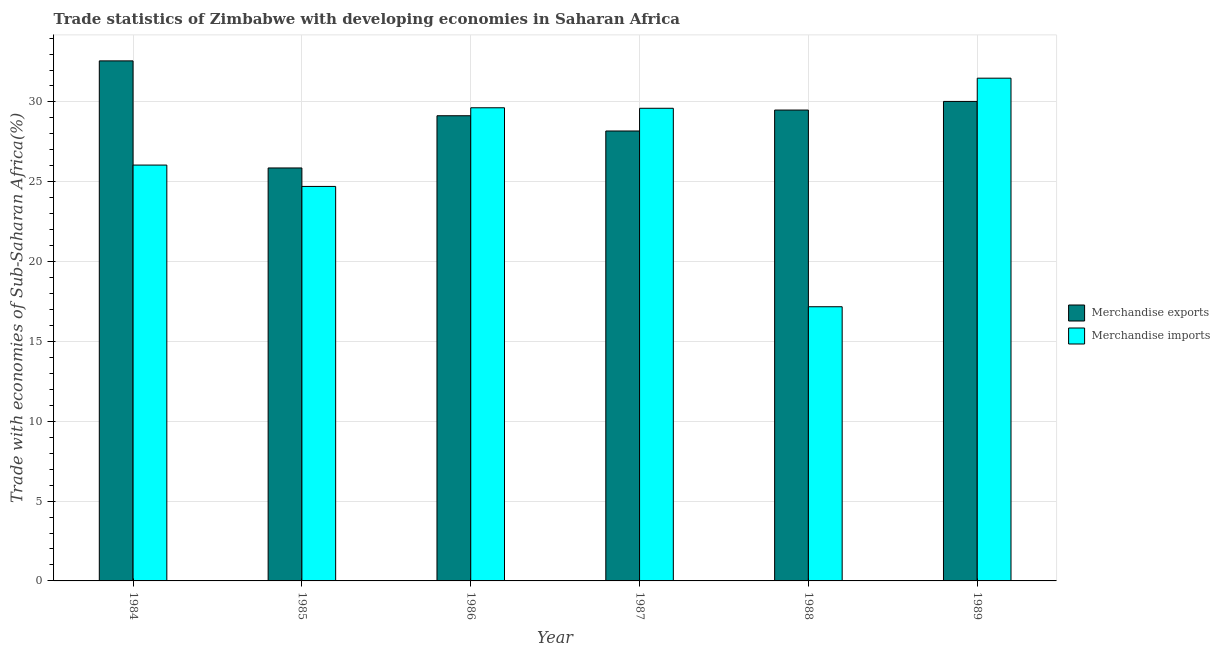How many different coloured bars are there?
Provide a short and direct response. 2. How many groups of bars are there?
Make the answer very short. 6. Are the number of bars on each tick of the X-axis equal?
Your answer should be very brief. Yes. How many bars are there on the 5th tick from the left?
Offer a very short reply. 2. How many bars are there on the 1st tick from the right?
Your response must be concise. 2. In how many cases, is the number of bars for a given year not equal to the number of legend labels?
Your answer should be compact. 0. What is the merchandise imports in 1989?
Make the answer very short. 31.49. Across all years, what is the maximum merchandise imports?
Your answer should be compact. 31.49. Across all years, what is the minimum merchandise imports?
Your answer should be compact. 17.17. In which year was the merchandise exports minimum?
Your response must be concise. 1985. What is the total merchandise exports in the graph?
Your answer should be compact. 175.28. What is the difference between the merchandise imports in 1986 and that in 1988?
Provide a short and direct response. 12.46. What is the difference between the merchandise imports in 1987 and the merchandise exports in 1989?
Your response must be concise. -1.88. What is the average merchandise exports per year?
Keep it short and to the point. 29.21. In the year 1988, what is the difference between the merchandise imports and merchandise exports?
Make the answer very short. 0. In how many years, is the merchandise exports greater than 29 %?
Provide a succinct answer. 4. What is the ratio of the merchandise imports in 1986 to that in 1988?
Offer a terse response. 1.73. Is the difference between the merchandise exports in 1985 and 1988 greater than the difference between the merchandise imports in 1985 and 1988?
Give a very brief answer. No. What is the difference between the highest and the second highest merchandise exports?
Give a very brief answer. 2.54. What is the difference between the highest and the lowest merchandise exports?
Offer a very short reply. 6.71. In how many years, is the merchandise exports greater than the average merchandise exports taken over all years?
Ensure brevity in your answer.  3. What does the 2nd bar from the left in 1989 represents?
Your answer should be very brief. Merchandise imports. What does the 2nd bar from the right in 1985 represents?
Make the answer very short. Merchandise exports. Are all the bars in the graph horizontal?
Offer a very short reply. No. What is the difference between two consecutive major ticks on the Y-axis?
Offer a terse response. 5. Does the graph contain grids?
Provide a succinct answer. Yes. Where does the legend appear in the graph?
Provide a short and direct response. Center right. How many legend labels are there?
Give a very brief answer. 2. How are the legend labels stacked?
Ensure brevity in your answer.  Vertical. What is the title of the graph?
Your answer should be compact. Trade statistics of Zimbabwe with developing economies in Saharan Africa. What is the label or title of the X-axis?
Keep it short and to the point. Year. What is the label or title of the Y-axis?
Provide a succinct answer. Trade with economies of Sub-Saharan Africa(%). What is the Trade with economies of Sub-Saharan Africa(%) of Merchandise exports in 1984?
Offer a terse response. 32.57. What is the Trade with economies of Sub-Saharan Africa(%) in Merchandise imports in 1984?
Offer a very short reply. 26.05. What is the Trade with economies of Sub-Saharan Africa(%) in Merchandise exports in 1985?
Offer a very short reply. 25.87. What is the Trade with economies of Sub-Saharan Africa(%) in Merchandise imports in 1985?
Your response must be concise. 24.71. What is the Trade with economies of Sub-Saharan Africa(%) of Merchandise exports in 1986?
Make the answer very short. 29.14. What is the Trade with economies of Sub-Saharan Africa(%) of Merchandise imports in 1986?
Give a very brief answer. 29.63. What is the Trade with economies of Sub-Saharan Africa(%) in Merchandise exports in 1987?
Offer a very short reply. 28.18. What is the Trade with economies of Sub-Saharan Africa(%) in Merchandise imports in 1987?
Provide a succinct answer. 29.6. What is the Trade with economies of Sub-Saharan Africa(%) in Merchandise exports in 1988?
Your answer should be very brief. 29.49. What is the Trade with economies of Sub-Saharan Africa(%) of Merchandise imports in 1988?
Offer a terse response. 17.17. What is the Trade with economies of Sub-Saharan Africa(%) in Merchandise exports in 1989?
Your answer should be compact. 30.03. What is the Trade with economies of Sub-Saharan Africa(%) in Merchandise imports in 1989?
Your answer should be very brief. 31.49. Across all years, what is the maximum Trade with economies of Sub-Saharan Africa(%) of Merchandise exports?
Offer a terse response. 32.57. Across all years, what is the maximum Trade with economies of Sub-Saharan Africa(%) of Merchandise imports?
Provide a short and direct response. 31.49. Across all years, what is the minimum Trade with economies of Sub-Saharan Africa(%) of Merchandise exports?
Offer a very short reply. 25.87. Across all years, what is the minimum Trade with economies of Sub-Saharan Africa(%) of Merchandise imports?
Provide a short and direct response. 17.17. What is the total Trade with economies of Sub-Saharan Africa(%) in Merchandise exports in the graph?
Give a very brief answer. 175.28. What is the total Trade with economies of Sub-Saharan Africa(%) in Merchandise imports in the graph?
Your answer should be very brief. 158.65. What is the difference between the Trade with economies of Sub-Saharan Africa(%) of Merchandise exports in 1984 and that in 1985?
Ensure brevity in your answer.  6.71. What is the difference between the Trade with economies of Sub-Saharan Africa(%) in Merchandise imports in 1984 and that in 1985?
Provide a short and direct response. 1.34. What is the difference between the Trade with economies of Sub-Saharan Africa(%) of Merchandise exports in 1984 and that in 1986?
Give a very brief answer. 3.44. What is the difference between the Trade with economies of Sub-Saharan Africa(%) in Merchandise imports in 1984 and that in 1986?
Provide a short and direct response. -3.59. What is the difference between the Trade with economies of Sub-Saharan Africa(%) of Merchandise exports in 1984 and that in 1987?
Make the answer very short. 4.39. What is the difference between the Trade with economies of Sub-Saharan Africa(%) of Merchandise imports in 1984 and that in 1987?
Make the answer very short. -3.56. What is the difference between the Trade with economies of Sub-Saharan Africa(%) in Merchandise exports in 1984 and that in 1988?
Offer a very short reply. 3.08. What is the difference between the Trade with economies of Sub-Saharan Africa(%) of Merchandise imports in 1984 and that in 1988?
Your answer should be compact. 8.87. What is the difference between the Trade with economies of Sub-Saharan Africa(%) of Merchandise exports in 1984 and that in 1989?
Ensure brevity in your answer.  2.54. What is the difference between the Trade with economies of Sub-Saharan Africa(%) in Merchandise imports in 1984 and that in 1989?
Give a very brief answer. -5.44. What is the difference between the Trade with economies of Sub-Saharan Africa(%) in Merchandise exports in 1985 and that in 1986?
Offer a terse response. -3.27. What is the difference between the Trade with economies of Sub-Saharan Africa(%) of Merchandise imports in 1985 and that in 1986?
Your answer should be compact. -4.93. What is the difference between the Trade with economies of Sub-Saharan Africa(%) in Merchandise exports in 1985 and that in 1987?
Your answer should be very brief. -2.32. What is the difference between the Trade with economies of Sub-Saharan Africa(%) in Merchandise imports in 1985 and that in 1987?
Provide a succinct answer. -4.9. What is the difference between the Trade with economies of Sub-Saharan Africa(%) in Merchandise exports in 1985 and that in 1988?
Your answer should be very brief. -3.63. What is the difference between the Trade with economies of Sub-Saharan Africa(%) in Merchandise imports in 1985 and that in 1988?
Provide a short and direct response. 7.54. What is the difference between the Trade with economies of Sub-Saharan Africa(%) of Merchandise exports in 1985 and that in 1989?
Your answer should be compact. -4.17. What is the difference between the Trade with economies of Sub-Saharan Africa(%) of Merchandise imports in 1985 and that in 1989?
Provide a succinct answer. -6.78. What is the difference between the Trade with economies of Sub-Saharan Africa(%) of Merchandise exports in 1986 and that in 1987?
Your answer should be compact. 0.95. What is the difference between the Trade with economies of Sub-Saharan Africa(%) of Merchandise imports in 1986 and that in 1987?
Your answer should be compact. 0.03. What is the difference between the Trade with economies of Sub-Saharan Africa(%) in Merchandise exports in 1986 and that in 1988?
Offer a terse response. -0.36. What is the difference between the Trade with economies of Sub-Saharan Africa(%) in Merchandise imports in 1986 and that in 1988?
Give a very brief answer. 12.46. What is the difference between the Trade with economies of Sub-Saharan Africa(%) of Merchandise exports in 1986 and that in 1989?
Provide a succinct answer. -0.9. What is the difference between the Trade with economies of Sub-Saharan Africa(%) of Merchandise imports in 1986 and that in 1989?
Keep it short and to the point. -1.85. What is the difference between the Trade with economies of Sub-Saharan Africa(%) of Merchandise exports in 1987 and that in 1988?
Your answer should be very brief. -1.31. What is the difference between the Trade with economies of Sub-Saharan Africa(%) in Merchandise imports in 1987 and that in 1988?
Your answer should be compact. 12.43. What is the difference between the Trade with economies of Sub-Saharan Africa(%) of Merchandise exports in 1987 and that in 1989?
Your response must be concise. -1.85. What is the difference between the Trade with economies of Sub-Saharan Africa(%) in Merchandise imports in 1987 and that in 1989?
Your response must be concise. -1.88. What is the difference between the Trade with economies of Sub-Saharan Africa(%) of Merchandise exports in 1988 and that in 1989?
Give a very brief answer. -0.54. What is the difference between the Trade with economies of Sub-Saharan Africa(%) of Merchandise imports in 1988 and that in 1989?
Your answer should be compact. -14.32. What is the difference between the Trade with economies of Sub-Saharan Africa(%) of Merchandise exports in 1984 and the Trade with economies of Sub-Saharan Africa(%) of Merchandise imports in 1985?
Your answer should be very brief. 7.86. What is the difference between the Trade with economies of Sub-Saharan Africa(%) in Merchandise exports in 1984 and the Trade with economies of Sub-Saharan Africa(%) in Merchandise imports in 1986?
Provide a succinct answer. 2.94. What is the difference between the Trade with economies of Sub-Saharan Africa(%) of Merchandise exports in 1984 and the Trade with economies of Sub-Saharan Africa(%) of Merchandise imports in 1987?
Ensure brevity in your answer.  2.97. What is the difference between the Trade with economies of Sub-Saharan Africa(%) in Merchandise exports in 1984 and the Trade with economies of Sub-Saharan Africa(%) in Merchandise imports in 1988?
Offer a very short reply. 15.4. What is the difference between the Trade with economies of Sub-Saharan Africa(%) of Merchandise exports in 1984 and the Trade with economies of Sub-Saharan Africa(%) of Merchandise imports in 1989?
Ensure brevity in your answer.  1.08. What is the difference between the Trade with economies of Sub-Saharan Africa(%) of Merchandise exports in 1985 and the Trade with economies of Sub-Saharan Africa(%) of Merchandise imports in 1986?
Give a very brief answer. -3.77. What is the difference between the Trade with economies of Sub-Saharan Africa(%) of Merchandise exports in 1985 and the Trade with economies of Sub-Saharan Africa(%) of Merchandise imports in 1987?
Your answer should be very brief. -3.74. What is the difference between the Trade with economies of Sub-Saharan Africa(%) of Merchandise exports in 1985 and the Trade with economies of Sub-Saharan Africa(%) of Merchandise imports in 1988?
Give a very brief answer. 8.69. What is the difference between the Trade with economies of Sub-Saharan Africa(%) in Merchandise exports in 1985 and the Trade with economies of Sub-Saharan Africa(%) in Merchandise imports in 1989?
Make the answer very short. -5.62. What is the difference between the Trade with economies of Sub-Saharan Africa(%) of Merchandise exports in 1986 and the Trade with economies of Sub-Saharan Africa(%) of Merchandise imports in 1987?
Keep it short and to the point. -0.47. What is the difference between the Trade with economies of Sub-Saharan Africa(%) of Merchandise exports in 1986 and the Trade with economies of Sub-Saharan Africa(%) of Merchandise imports in 1988?
Your answer should be very brief. 11.96. What is the difference between the Trade with economies of Sub-Saharan Africa(%) in Merchandise exports in 1986 and the Trade with economies of Sub-Saharan Africa(%) in Merchandise imports in 1989?
Keep it short and to the point. -2.35. What is the difference between the Trade with economies of Sub-Saharan Africa(%) of Merchandise exports in 1987 and the Trade with economies of Sub-Saharan Africa(%) of Merchandise imports in 1988?
Ensure brevity in your answer.  11.01. What is the difference between the Trade with economies of Sub-Saharan Africa(%) in Merchandise exports in 1987 and the Trade with economies of Sub-Saharan Africa(%) in Merchandise imports in 1989?
Make the answer very short. -3.31. What is the difference between the Trade with economies of Sub-Saharan Africa(%) of Merchandise exports in 1988 and the Trade with economies of Sub-Saharan Africa(%) of Merchandise imports in 1989?
Give a very brief answer. -2. What is the average Trade with economies of Sub-Saharan Africa(%) of Merchandise exports per year?
Offer a very short reply. 29.21. What is the average Trade with economies of Sub-Saharan Africa(%) of Merchandise imports per year?
Your answer should be compact. 26.44. In the year 1984, what is the difference between the Trade with economies of Sub-Saharan Africa(%) in Merchandise exports and Trade with economies of Sub-Saharan Africa(%) in Merchandise imports?
Offer a very short reply. 6.53. In the year 1985, what is the difference between the Trade with economies of Sub-Saharan Africa(%) of Merchandise exports and Trade with economies of Sub-Saharan Africa(%) of Merchandise imports?
Your answer should be very brief. 1.16. In the year 1986, what is the difference between the Trade with economies of Sub-Saharan Africa(%) of Merchandise exports and Trade with economies of Sub-Saharan Africa(%) of Merchandise imports?
Provide a short and direct response. -0.5. In the year 1987, what is the difference between the Trade with economies of Sub-Saharan Africa(%) in Merchandise exports and Trade with economies of Sub-Saharan Africa(%) in Merchandise imports?
Your answer should be very brief. -1.42. In the year 1988, what is the difference between the Trade with economies of Sub-Saharan Africa(%) of Merchandise exports and Trade with economies of Sub-Saharan Africa(%) of Merchandise imports?
Your answer should be compact. 12.32. In the year 1989, what is the difference between the Trade with economies of Sub-Saharan Africa(%) in Merchandise exports and Trade with economies of Sub-Saharan Africa(%) in Merchandise imports?
Your answer should be compact. -1.46. What is the ratio of the Trade with economies of Sub-Saharan Africa(%) in Merchandise exports in 1984 to that in 1985?
Provide a short and direct response. 1.26. What is the ratio of the Trade with economies of Sub-Saharan Africa(%) in Merchandise imports in 1984 to that in 1985?
Keep it short and to the point. 1.05. What is the ratio of the Trade with economies of Sub-Saharan Africa(%) in Merchandise exports in 1984 to that in 1986?
Offer a very short reply. 1.12. What is the ratio of the Trade with economies of Sub-Saharan Africa(%) in Merchandise imports in 1984 to that in 1986?
Your response must be concise. 0.88. What is the ratio of the Trade with economies of Sub-Saharan Africa(%) of Merchandise exports in 1984 to that in 1987?
Provide a short and direct response. 1.16. What is the ratio of the Trade with economies of Sub-Saharan Africa(%) in Merchandise imports in 1984 to that in 1987?
Offer a very short reply. 0.88. What is the ratio of the Trade with economies of Sub-Saharan Africa(%) in Merchandise exports in 1984 to that in 1988?
Your answer should be compact. 1.1. What is the ratio of the Trade with economies of Sub-Saharan Africa(%) of Merchandise imports in 1984 to that in 1988?
Your response must be concise. 1.52. What is the ratio of the Trade with economies of Sub-Saharan Africa(%) of Merchandise exports in 1984 to that in 1989?
Your answer should be compact. 1.08. What is the ratio of the Trade with economies of Sub-Saharan Africa(%) in Merchandise imports in 1984 to that in 1989?
Your answer should be compact. 0.83. What is the ratio of the Trade with economies of Sub-Saharan Africa(%) of Merchandise exports in 1985 to that in 1986?
Your answer should be compact. 0.89. What is the ratio of the Trade with economies of Sub-Saharan Africa(%) of Merchandise imports in 1985 to that in 1986?
Offer a very short reply. 0.83. What is the ratio of the Trade with economies of Sub-Saharan Africa(%) of Merchandise exports in 1985 to that in 1987?
Your answer should be compact. 0.92. What is the ratio of the Trade with economies of Sub-Saharan Africa(%) of Merchandise imports in 1985 to that in 1987?
Make the answer very short. 0.83. What is the ratio of the Trade with economies of Sub-Saharan Africa(%) in Merchandise exports in 1985 to that in 1988?
Ensure brevity in your answer.  0.88. What is the ratio of the Trade with economies of Sub-Saharan Africa(%) in Merchandise imports in 1985 to that in 1988?
Keep it short and to the point. 1.44. What is the ratio of the Trade with economies of Sub-Saharan Africa(%) in Merchandise exports in 1985 to that in 1989?
Provide a short and direct response. 0.86. What is the ratio of the Trade with economies of Sub-Saharan Africa(%) in Merchandise imports in 1985 to that in 1989?
Offer a terse response. 0.78. What is the ratio of the Trade with economies of Sub-Saharan Africa(%) in Merchandise exports in 1986 to that in 1987?
Offer a terse response. 1.03. What is the ratio of the Trade with economies of Sub-Saharan Africa(%) in Merchandise imports in 1986 to that in 1987?
Offer a very short reply. 1. What is the ratio of the Trade with economies of Sub-Saharan Africa(%) in Merchandise exports in 1986 to that in 1988?
Provide a short and direct response. 0.99. What is the ratio of the Trade with economies of Sub-Saharan Africa(%) in Merchandise imports in 1986 to that in 1988?
Keep it short and to the point. 1.73. What is the ratio of the Trade with economies of Sub-Saharan Africa(%) of Merchandise exports in 1986 to that in 1989?
Provide a short and direct response. 0.97. What is the ratio of the Trade with economies of Sub-Saharan Africa(%) in Merchandise imports in 1986 to that in 1989?
Give a very brief answer. 0.94. What is the ratio of the Trade with economies of Sub-Saharan Africa(%) in Merchandise exports in 1987 to that in 1988?
Provide a succinct answer. 0.96. What is the ratio of the Trade with economies of Sub-Saharan Africa(%) of Merchandise imports in 1987 to that in 1988?
Your response must be concise. 1.72. What is the ratio of the Trade with economies of Sub-Saharan Africa(%) of Merchandise exports in 1987 to that in 1989?
Give a very brief answer. 0.94. What is the ratio of the Trade with economies of Sub-Saharan Africa(%) of Merchandise imports in 1987 to that in 1989?
Your answer should be very brief. 0.94. What is the ratio of the Trade with economies of Sub-Saharan Africa(%) in Merchandise imports in 1988 to that in 1989?
Provide a succinct answer. 0.55. What is the difference between the highest and the second highest Trade with economies of Sub-Saharan Africa(%) in Merchandise exports?
Your answer should be compact. 2.54. What is the difference between the highest and the second highest Trade with economies of Sub-Saharan Africa(%) in Merchandise imports?
Give a very brief answer. 1.85. What is the difference between the highest and the lowest Trade with economies of Sub-Saharan Africa(%) in Merchandise exports?
Your response must be concise. 6.71. What is the difference between the highest and the lowest Trade with economies of Sub-Saharan Africa(%) in Merchandise imports?
Ensure brevity in your answer.  14.32. 